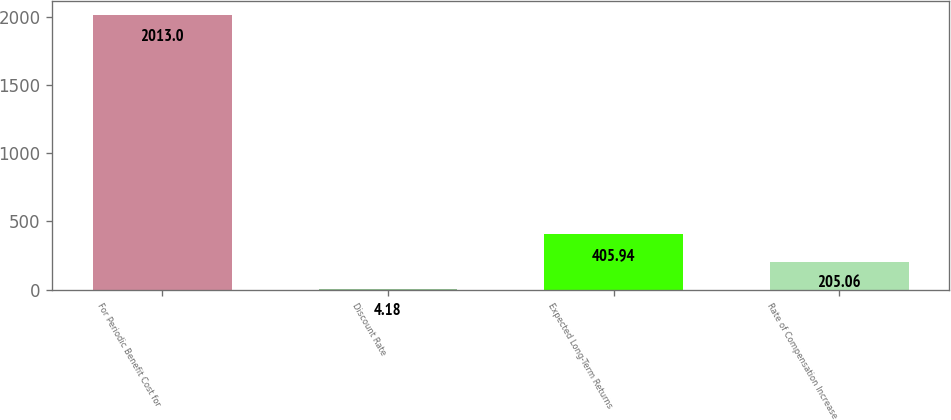<chart> <loc_0><loc_0><loc_500><loc_500><bar_chart><fcel>For Periodic Benefit Cost for<fcel>Discount Rate<fcel>Expected Long-Term Returns<fcel>Rate of Compensation Increase<nl><fcel>2013<fcel>4.18<fcel>405.94<fcel>205.06<nl></chart> 